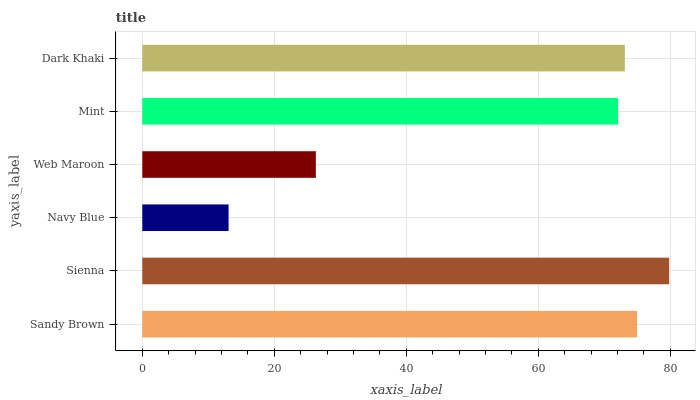Is Navy Blue the minimum?
Answer yes or no. Yes. Is Sienna the maximum?
Answer yes or no. Yes. Is Sienna the minimum?
Answer yes or no. No. Is Navy Blue the maximum?
Answer yes or no. No. Is Sienna greater than Navy Blue?
Answer yes or no. Yes. Is Navy Blue less than Sienna?
Answer yes or no. Yes. Is Navy Blue greater than Sienna?
Answer yes or no. No. Is Sienna less than Navy Blue?
Answer yes or no. No. Is Dark Khaki the high median?
Answer yes or no. Yes. Is Mint the low median?
Answer yes or no. Yes. Is Sienna the high median?
Answer yes or no. No. Is Navy Blue the low median?
Answer yes or no. No. 